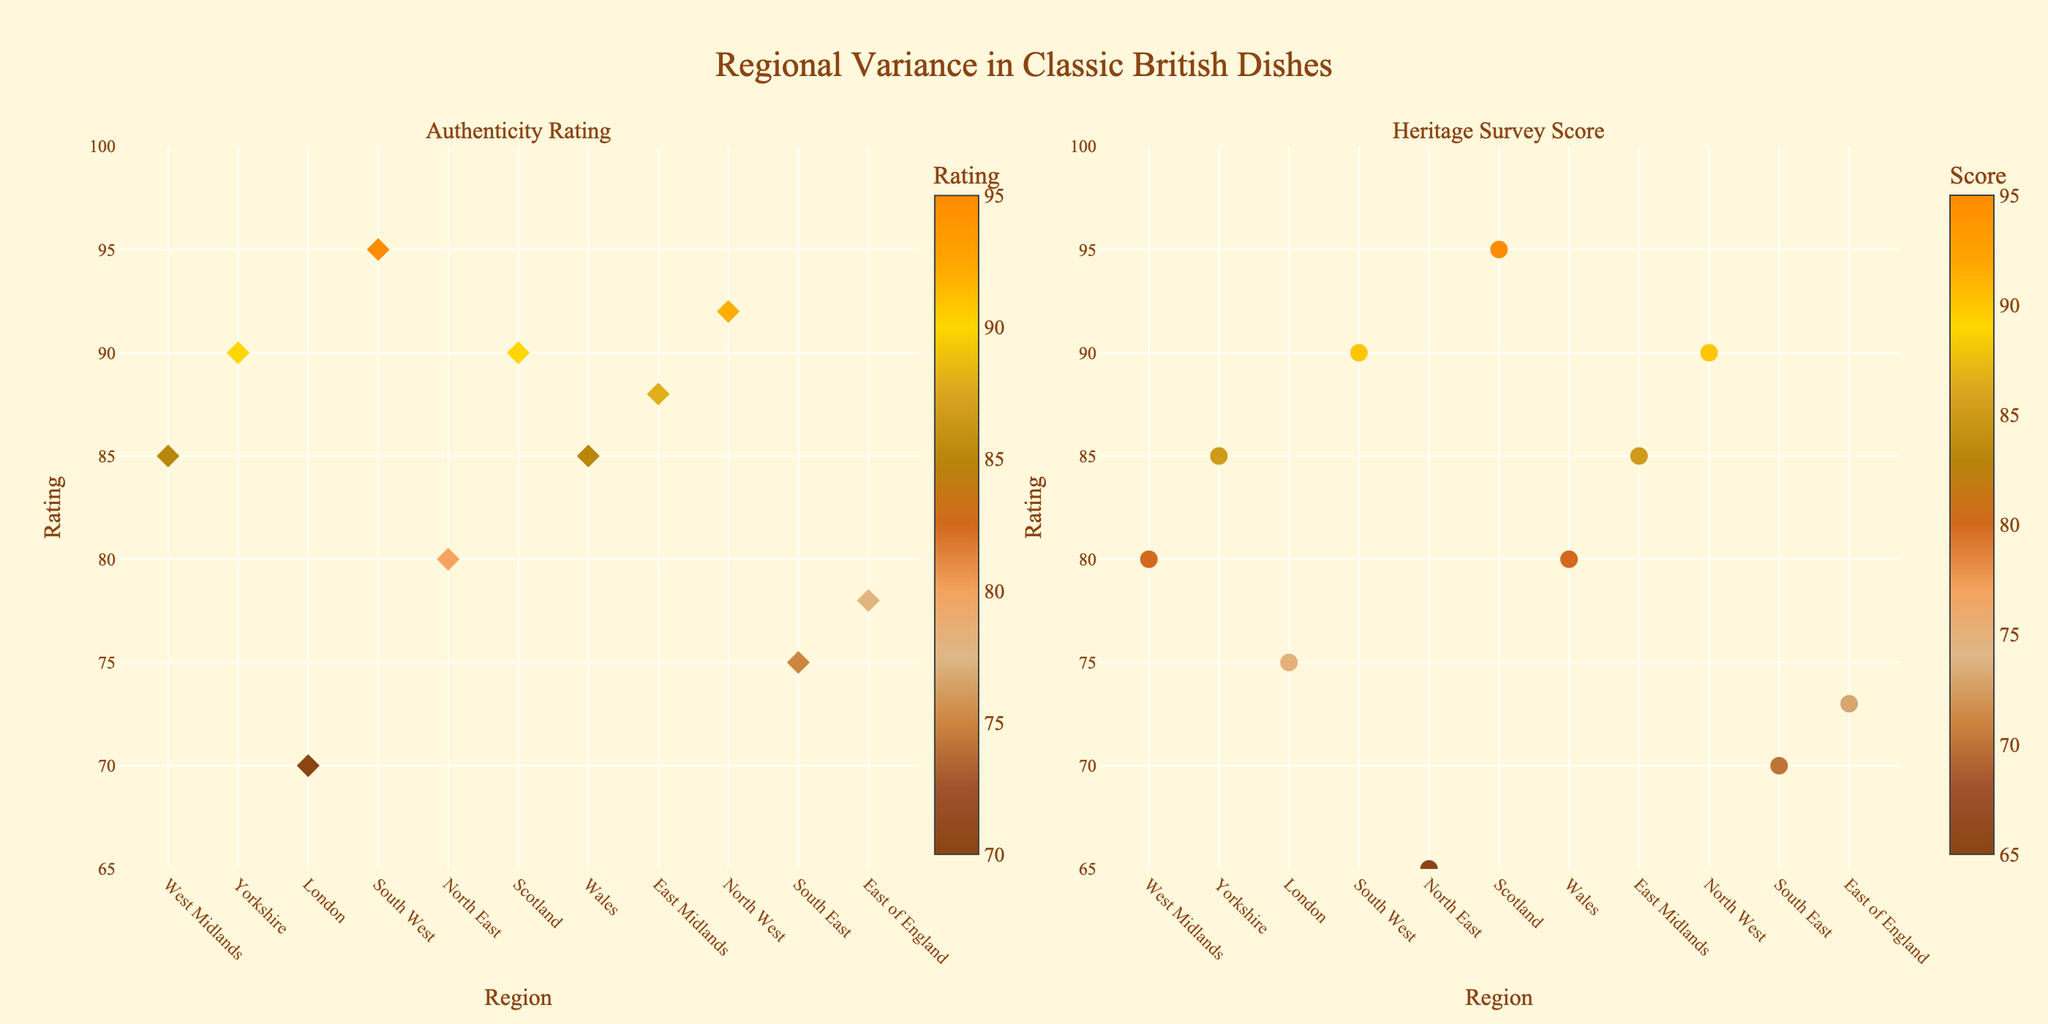What is the title of the plot? The title is displayed at the top center of the plot in a larger and bolder font. It reads "Regional Variance in Classic British Dishes".
Answer: Regional Variance in Classic British Dishes Which region has the highest Authenticity Rating? Look at the left subplot titled "Authenticity Rating" and identify the region with the highest value on the y-axis. Here, "South West" with the dish "Cornish Pasty" scores 95, the highest value.
Answer: South West Which region has the lowest Heritage Survey Score? Look at the right subplot titled "Heritage Survey Score" and find the region with the lowest value on the y-axis. The "North East" region with the dish "Stottie Cake" has the lowest score, which is 65.
Answer: North East Which dish has the most consistent high scores between Authenticity Rating and Heritage Survey Score? Compare both subplots to find the dish with closely matched high scores. "Haggis" from Scotland appears very consistent with an Authenticity Rating of 90 and Heritage Survey Score of 95.
Answer: Haggis What is the difference in Authenticity Rating between the South West and London? Calculate by subtracting the Authenticity Rating of London (70) from the South West (95). The difference is 95 - 70 = 25.
Answer: 25 Which region shows a significant discrepancy between its ratings in the two subplots? By comparing both ratings for each region, "North East" stands out with an Authenticity Rating of 80 versus a much lower Heritage Survey Score of 65.
Answer: North East How many regions have an Authenticity Rating of 85 or higher? Count the number of regions on the left subplot where the Authenticity Rating is 85 or more. Regions are West Midlands, Yorkshire, South West, Scotland, Wales, East Midlands, North West. Thus, 7 in total.
Answer: 7 Which region is placed to the far left on both subplots? Identify the region at the farthest left position on both the x-axes. In both cases, it is "West Midlands".
Answer: West Midlands What is the average Heritage Survey Score for dishes with an Authenticity Rating over 85? List regions with an Authenticity Rating over 85: West Midlands (80), Yorkshire (85), South West (90), Scotland (95), Wales (80), East Midlands (85), North West (90). Sum these scores (80 + 85 + 90 + 95 + 80 + 85 + 90 = 605) and divide by the number of regions (7). The average is 605/7 ≈ 86.43.
Answer: 86.43 